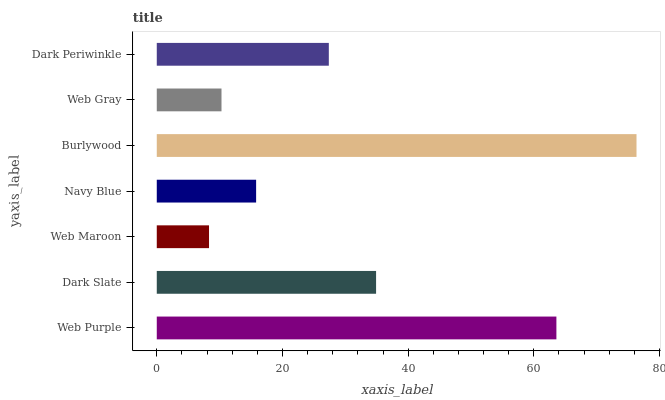Is Web Maroon the minimum?
Answer yes or no. Yes. Is Burlywood the maximum?
Answer yes or no. Yes. Is Dark Slate the minimum?
Answer yes or no. No. Is Dark Slate the maximum?
Answer yes or no. No. Is Web Purple greater than Dark Slate?
Answer yes or no. Yes. Is Dark Slate less than Web Purple?
Answer yes or no. Yes. Is Dark Slate greater than Web Purple?
Answer yes or no. No. Is Web Purple less than Dark Slate?
Answer yes or no. No. Is Dark Periwinkle the high median?
Answer yes or no. Yes. Is Dark Periwinkle the low median?
Answer yes or no. Yes. Is Dark Slate the high median?
Answer yes or no. No. Is Burlywood the low median?
Answer yes or no. No. 